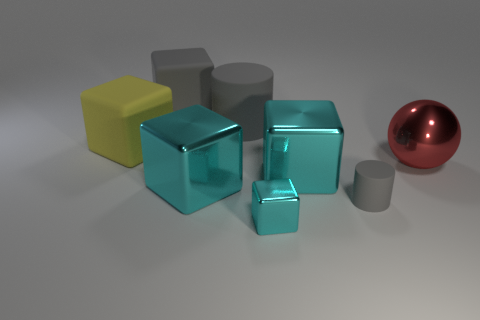How many cyan cubes must be subtracted to get 1 cyan cubes? 2 Subtract all red cylinders. How many cyan cubes are left? 3 Add 2 cubes. How many objects exist? 10 Subtract all big shiny cubes. How many cubes are left? 3 Subtract all yellow blocks. How many blocks are left? 4 Subtract all balls. How many objects are left? 7 Add 6 small matte things. How many small matte things exist? 7 Subtract 0 cyan cylinders. How many objects are left? 8 Subtract all brown blocks. Subtract all blue cylinders. How many blocks are left? 5 Subtract all cyan metallic things. Subtract all tiny cylinders. How many objects are left? 4 